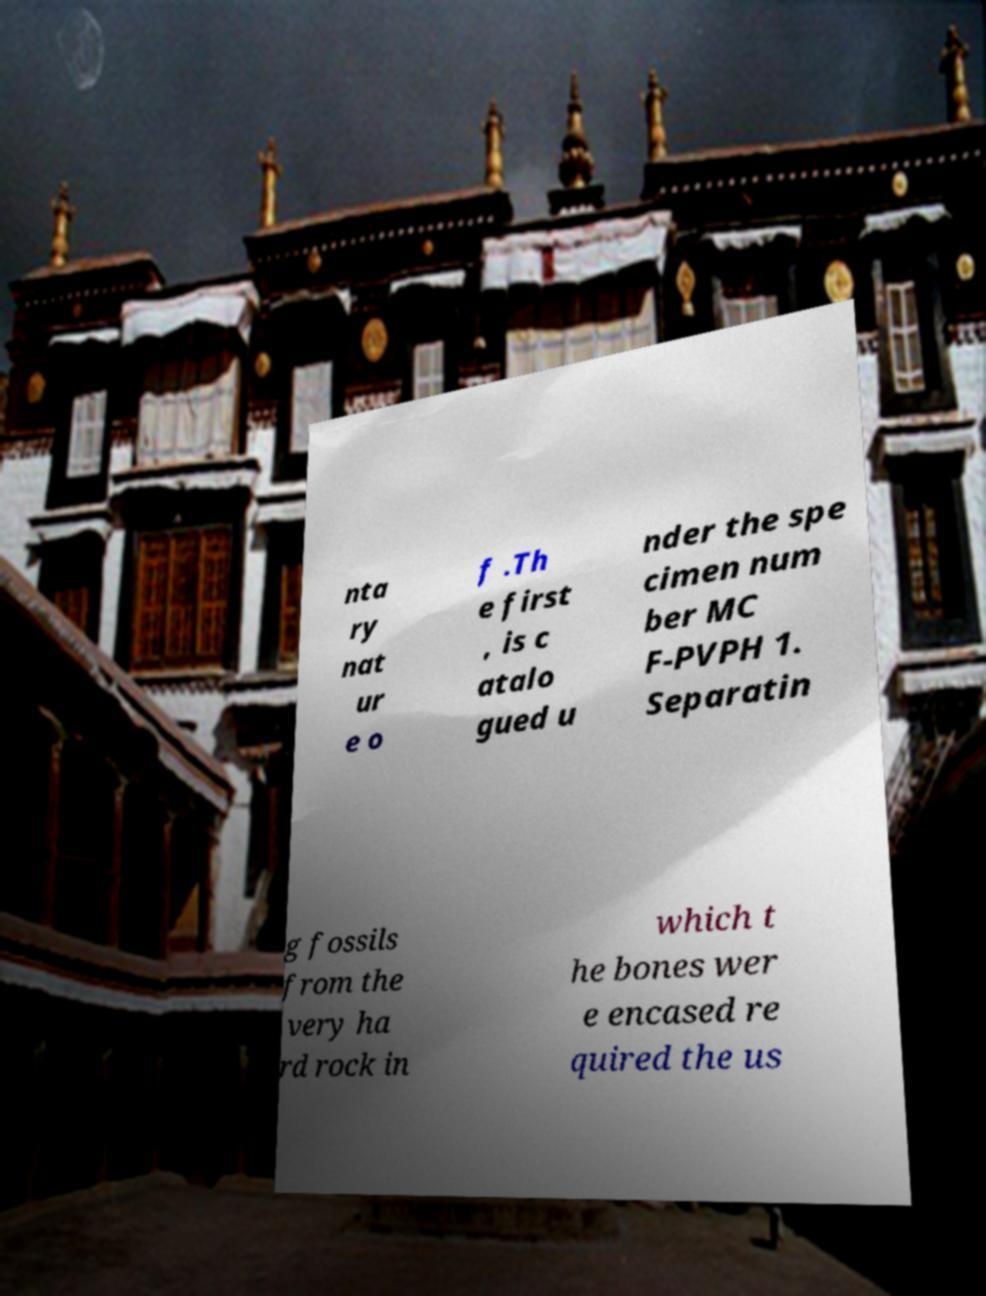Could you extract and type out the text from this image? nta ry nat ur e o f .Th e first , is c atalo gued u nder the spe cimen num ber MC F-PVPH 1. Separatin g fossils from the very ha rd rock in which t he bones wer e encased re quired the us 